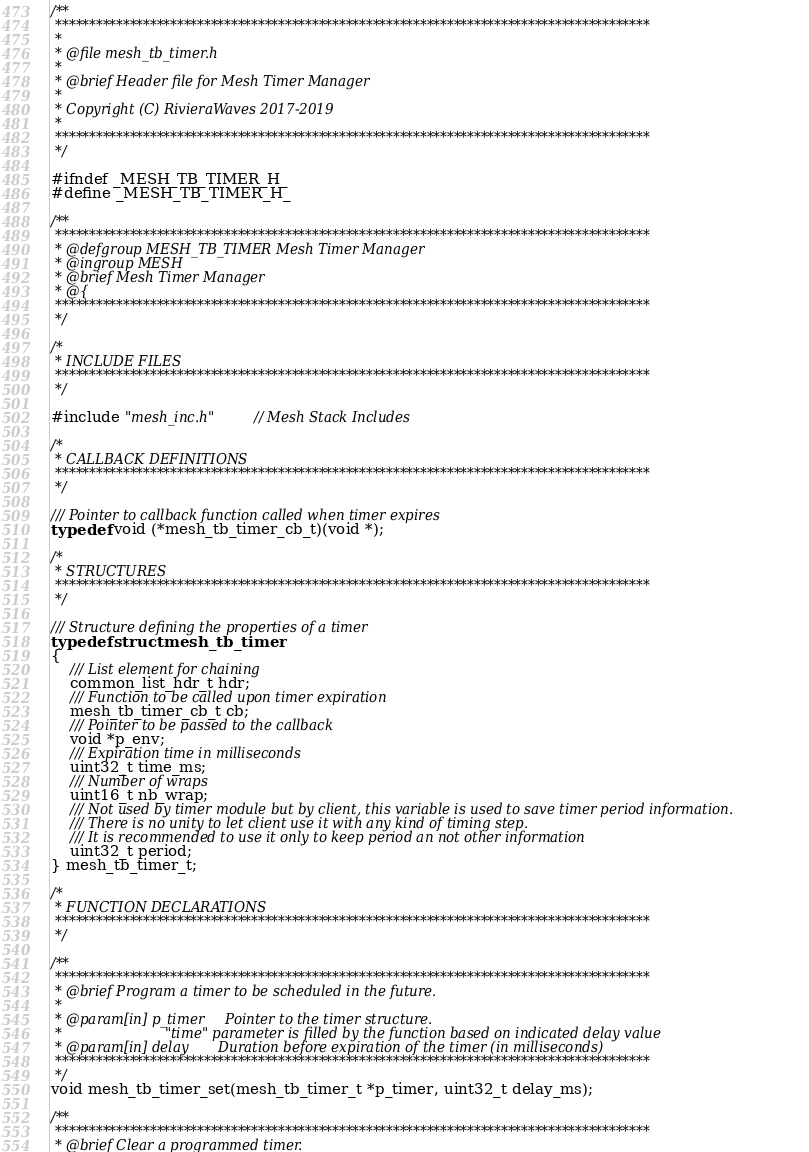Convert code to text. <code><loc_0><loc_0><loc_500><loc_500><_C_>/**
 ****************************************************************************************
 *
 * @file mesh_tb_timer.h
 *
 * @brief Header file for Mesh Timer Manager
 *
 * Copyright (C) RivieraWaves 2017-2019
 *
 ****************************************************************************************
 */

#ifndef _MESH_TB_TIMER_H_
#define _MESH_TB_TIMER_H_

/**
 ****************************************************************************************
 * @defgroup MESH_TB_TIMER Mesh Timer Manager
 * @ingroup MESH
 * @brief Mesh Timer Manager
 * @{
 ****************************************************************************************
 */

/*
 * INCLUDE FILES
 ****************************************************************************************
 */

#include "mesh_inc.h"       // Mesh Stack Includes

/*
 * CALLBACK DEFINITIONS
 ****************************************************************************************
 */

/// Pointer to callback function called when timer expires
typedef void (*mesh_tb_timer_cb_t)(void *);

/*
 * STRUCTURES
 ****************************************************************************************
 */

/// Structure defining the properties of a timer
typedef struct mesh_tb_timer
{
    /// List element for chaining
    common_list_hdr_t hdr;
    /// Function to be called upon timer expiration
    mesh_tb_timer_cb_t cb;
    /// Pointer to be passed to the callback
    void *p_env;
    /// Expiration time in milliseconds
    uint32_t time_ms;
    /// Number of wraps
    uint16_t nb_wrap;
    /// Not used by timer module but by client, this variable is used to save timer period information.
    /// There is no unity to let client use it with any kind of timing step.
    /// It is recommended to use it only to keep period an not other information
    uint32_t period;
} mesh_tb_timer_t;

/*
 * FUNCTION DECLARATIONS
 ****************************************************************************************
 */

/**
 ****************************************************************************************
 * @brief Program a timer to be scheduled in the future.
 *
 * @param[in] p_timer     Pointer to the timer structure.
 *                        "time" parameter is filled by the function based on indicated delay value
 * @param[in] delay       Duration before expiration of the timer (in milliseconds)
 ****************************************************************************************
 */
void mesh_tb_timer_set(mesh_tb_timer_t *p_timer, uint32_t delay_ms);

/**
 ****************************************************************************************
 * @brief Clear a programmed timer.</code> 